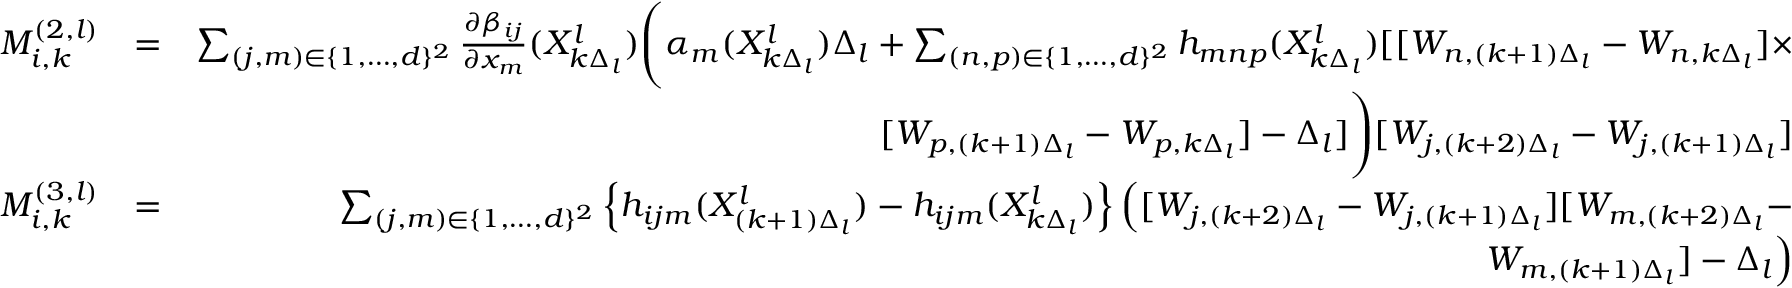Convert formula to latex. <formula><loc_0><loc_0><loc_500><loc_500>\begin{array} { r l r } { M _ { i , k } ^ { ( 2 , l ) } } & { = } & { \sum _ { ( j , m ) \in \{ 1 , \dots , d \} ^ { 2 } } \frac { \partial \beta _ { i j } } { \partial x _ { m } } ( X _ { k \Delta _ { l } } ^ { l } ) \left ( \alpha _ { m } ( X _ { k \Delta _ { l } } ^ { l } ) \Delta _ { l } + \sum _ { ( n , p ) \in \{ 1 , \dots , d \} ^ { 2 } } h _ { m n p } ( X _ { k \Delta _ { l } } ^ { l } ) [ [ W _ { n , ( k + 1 ) \Delta _ { l } } - W _ { n , k \Delta _ { l } } ] \times } \\ & { [ W _ { p , ( k + 1 ) \Delta _ { l } } - W _ { p , k \Delta _ { l } } ] - \Delta _ { l } ] \right ) [ W _ { j , ( k + 2 ) \Delta _ { l } } - W _ { j , ( k + 1 ) \Delta _ { l } } ] } \\ { M _ { i , k } ^ { ( 3 , l ) } } & { = } & { \sum _ { ( j , m ) \in \{ 1 , \dots , d \} ^ { 2 } } \left \{ h _ { i j m } ( X _ { ( k + 1 ) \Delta _ { l } } ^ { l } ) - h _ { i j m } ( X _ { k \Delta _ { l } } ^ { l } ) \right \} \left ( [ W _ { j , ( k + 2 ) \Delta _ { l } } - W _ { j , ( k + 1 ) \Delta _ { l } } ] [ W _ { m , ( k + 2 ) \Delta _ { l } } - } \\ & { W _ { m , ( k + 1 ) \Delta _ { l } } ] - \Delta _ { l } \right ) } \end{array}</formula> 